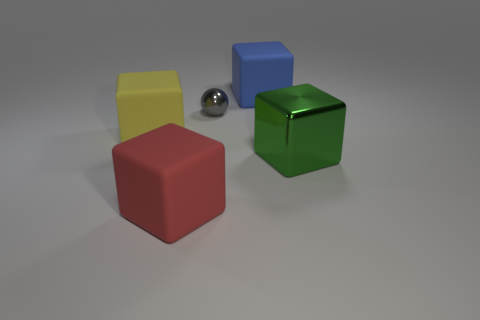Is there anything else that is the same size as the shiny ball?
Give a very brief answer. No. Are there any other rubber things that have the same color as the tiny thing?
Your answer should be very brief. No. How many large things are gray metallic balls or blocks?
Offer a very short reply. 4. How big is the block that is both in front of the large blue rubber block and behind the large metallic thing?
Provide a succinct answer. Large. There is a tiny sphere; how many large metal objects are to the right of it?
Keep it short and to the point. 1. There is a large thing that is behind the big green shiny block and right of the red object; what shape is it?
Your answer should be compact. Cube. How many cylinders are either large gray metal objects or large metallic objects?
Provide a short and direct response. 0. Is the number of metal blocks behind the yellow matte cube less than the number of yellow matte cubes?
Your answer should be compact. Yes. There is a big object that is both behind the big shiny object and to the right of the tiny sphere; what is its color?
Provide a short and direct response. Blue. How many other objects are the same shape as the tiny metallic thing?
Your answer should be very brief. 0. 